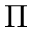<formula> <loc_0><loc_0><loc_500><loc_500>\Pi</formula> 